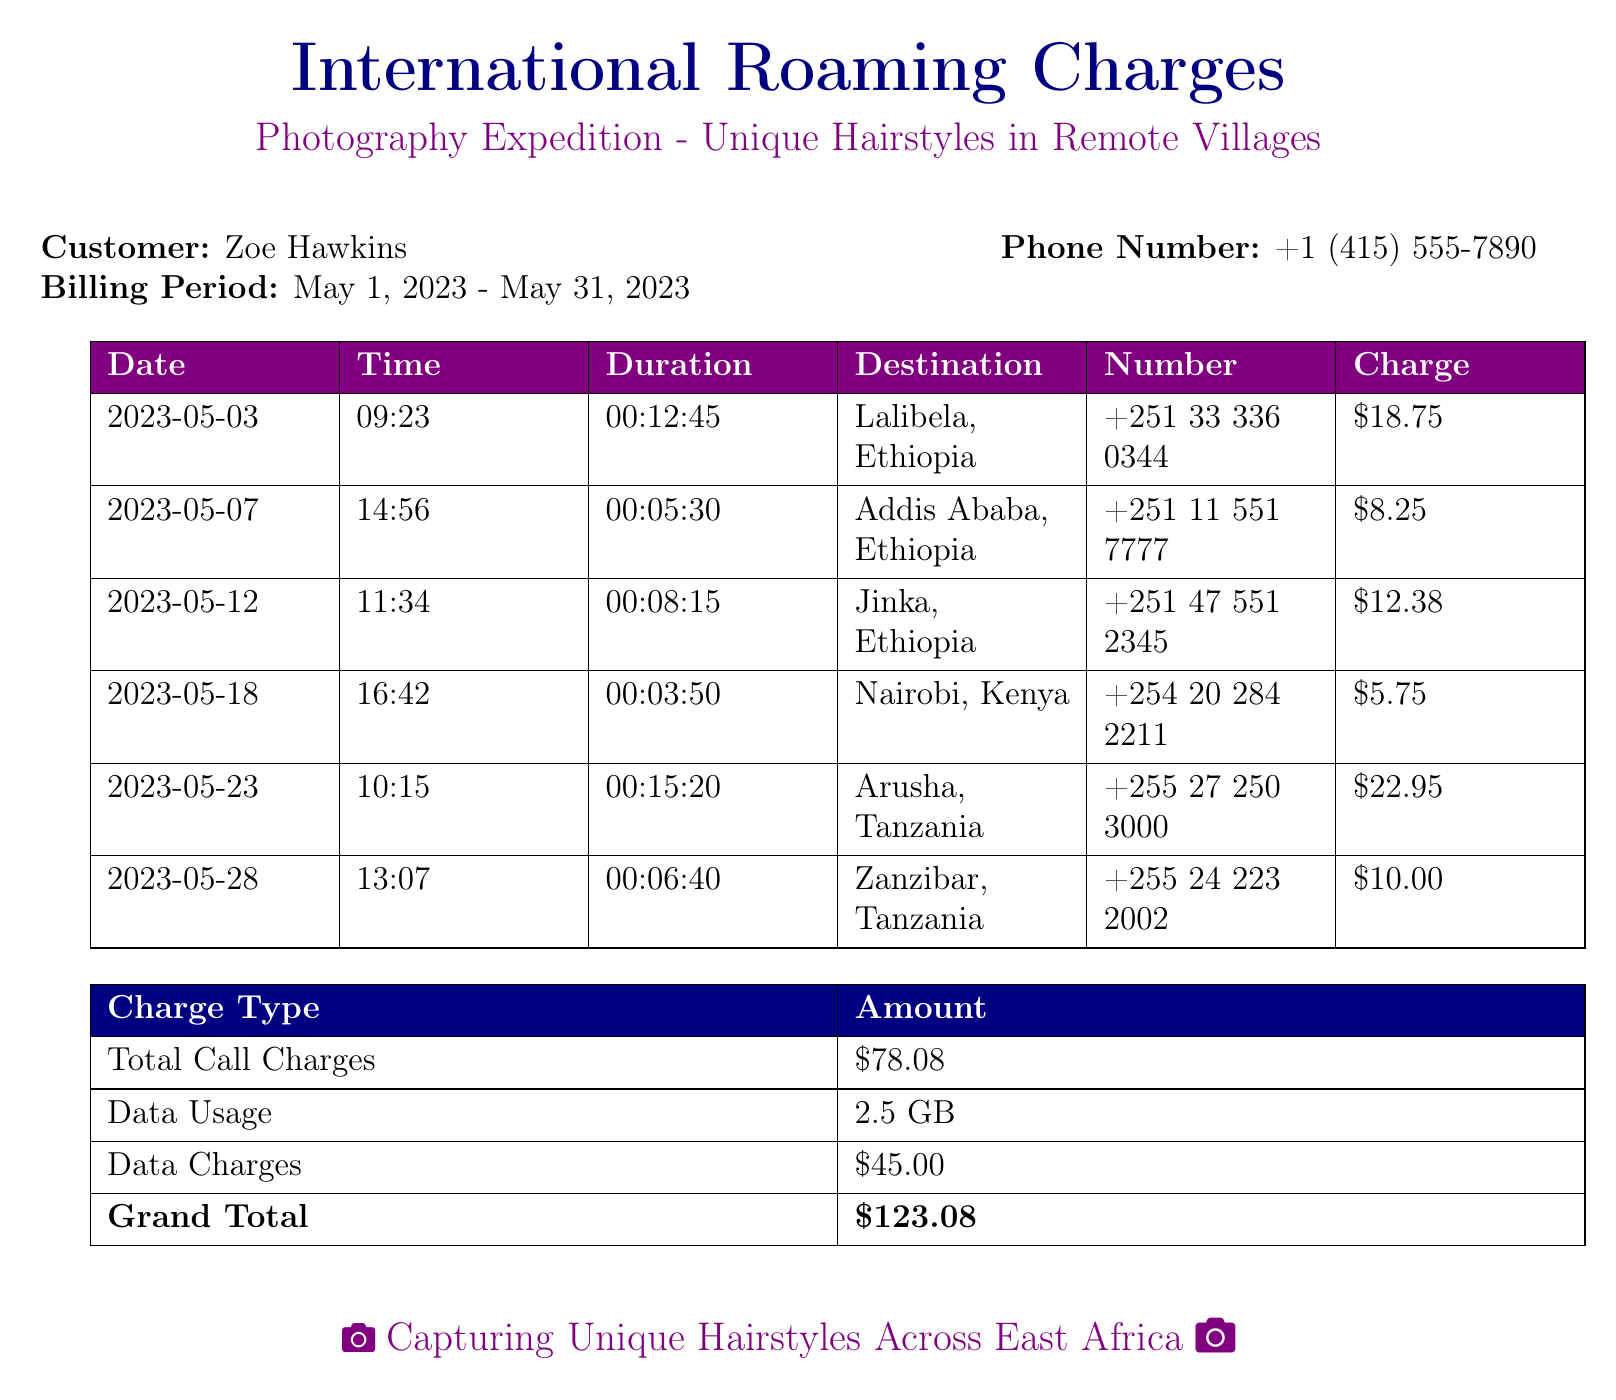What is the customer's name? The document states that the customer's name is Zoe Hawkins.
Answer: Zoe Hawkins What is the total call charge? The total call charge is specifically listed in the document, which is $78.08.
Answer: $78.08 Which country did the call on May 3rd go to? The call on May 3rd was made to Lalibela, Ethiopia, as noted in the log.
Answer: Lalibela, Ethiopia How many minutes were spent on the call to Zanzibar, Tanzania? The duration of the call to Zanzibar is recorded as 6 minutes and 40 seconds.
Answer: 6 minutes and 40 seconds What was the charge for the call to Arusha? The charge for the call to Arusha is mentioned as $22.95 in the document.
Answer: $22.95 What is the total data usage recorded? The document highlights that a total of 2.5 GB of data was used.
Answer: 2.5 GB What is the grand total of all charges? The grand total, combining all charges, is specified as $123.08.
Answer: $123.08 How long was the call to Nairobi? The duration of the call to Nairobi is stated in the document as 3 minutes and 50 seconds.
Answer: 3 minutes and 50 seconds What type of document is this? The document is a detailed telephone record of international roaming charges, as indicated in the title.
Answer: Telephone record 